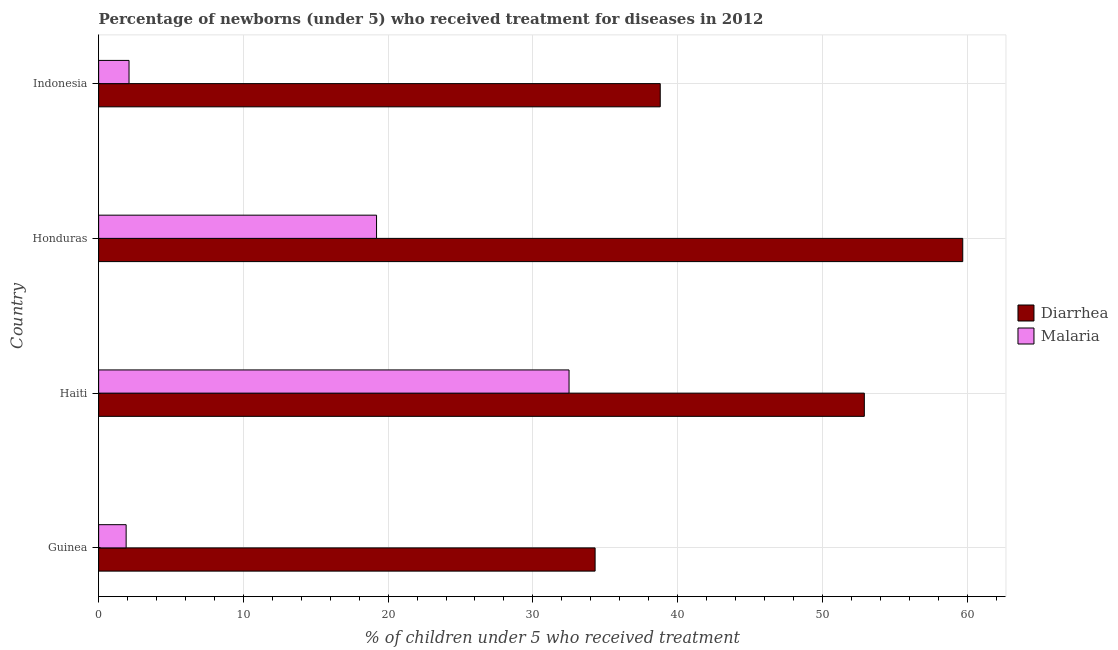How many groups of bars are there?
Your answer should be very brief. 4. Are the number of bars on each tick of the Y-axis equal?
Your answer should be compact. Yes. How many bars are there on the 1st tick from the top?
Your response must be concise. 2. What is the label of the 4th group of bars from the top?
Keep it short and to the point. Guinea. In how many cases, is the number of bars for a given country not equal to the number of legend labels?
Your answer should be compact. 0. What is the percentage of children who received treatment for diarrhoea in Haiti?
Keep it short and to the point. 52.9. Across all countries, what is the maximum percentage of children who received treatment for diarrhoea?
Your answer should be compact. 59.7. In which country was the percentage of children who received treatment for diarrhoea maximum?
Provide a succinct answer. Honduras. In which country was the percentage of children who received treatment for malaria minimum?
Provide a short and direct response. Guinea. What is the total percentage of children who received treatment for malaria in the graph?
Your answer should be compact. 55.7. What is the difference between the percentage of children who received treatment for malaria in Guinea and the percentage of children who received treatment for diarrhoea in Haiti?
Your answer should be compact. -51. What is the average percentage of children who received treatment for diarrhoea per country?
Give a very brief answer. 46.42. What is the difference between the percentage of children who received treatment for malaria and percentage of children who received treatment for diarrhoea in Honduras?
Your response must be concise. -40.5. In how many countries, is the percentage of children who received treatment for malaria greater than 44 %?
Provide a short and direct response. 0. What is the ratio of the percentage of children who received treatment for malaria in Haiti to that in Indonesia?
Give a very brief answer. 15.48. Is the percentage of children who received treatment for malaria in Guinea less than that in Honduras?
Your response must be concise. Yes. What is the difference between the highest and the lowest percentage of children who received treatment for diarrhoea?
Keep it short and to the point. 25.4. In how many countries, is the percentage of children who received treatment for diarrhoea greater than the average percentage of children who received treatment for diarrhoea taken over all countries?
Give a very brief answer. 2. What does the 1st bar from the top in Haiti represents?
Give a very brief answer. Malaria. What does the 2nd bar from the bottom in Honduras represents?
Give a very brief answer. Malaria. How many bars are there?
Make the answer very short. 8. Are all the bars in the graph horizontal?
Offer a terse response. Yes. Does the graph contain any zero values?
Offer a very short reply. No. Does the graph contain grids?
Your answer should be compact. Yes. How are the legend labels stacked?
Offer a terse response. Vertical. What is the title of the graph?
Provide a short and direct response. Percentage of newborns (under 5) who received treatment for diseases in 2012. Does "Mineral" appear as one of the legend labels in the graph?
Provide a succinct answer. No. What is the label or title of the X-axis?
Offer a very short reply. % of children under 5 who received treatment. What is the label or title of the Y-axis?
Offer a terse response. Country. What is the % of children under 5 who received treatment of Diarrhea in Guinea?
Your answer should be compact. 34.3. What is the % of children under 5 who received treatment of Malaria in Guinea?
Offer a terse response. 1.9. What is the % of children under 5 who received treatment of Diarrhea in Haiti?
Provide a succinct answer. 52.9. What is the % of children under 5 who received treatment in Malaria in Haiti?
Keep it short and to the point. 32.5. What is the % of children under 5 who received treatment in Diarrhea in Honduras?
Offer a very short reply. 59.7. What is the % of children under 5 who received treatment in Diarrhea in Indonesia?
Give a very brief answer. 38.8. What is the % of children under 5 who received treatment of Malaria in Indonesia?
Provide a succinct answer. 2.1. Across all countries, what is the maximum % of children under 5 who received treatment in Diarrhea?
Make the answer very short. 59.7. Across all countries, what is the maximum % of children under 5 who received treatment of Malaria?
Ensure brevity in your answer.  32.5. Across all countries, what is the minimum % of children under 5 who received treatment of Diarrhea?
Your response must be concise. 34.3. Across all countries, what is the minimum % of children under 5 who received treatment in Malaria?
Your response must be concise. 1.9. What is the total % of children under 5 who received treatment of Diarrhea in the graph?
Ensure brevity in your answer.  185.7. What is the total % of children under 5 who received treatment of Malaria in the graph?
Provide a succinct answer. 55.7. What is the difference between the % of children under 5 who received treatment of Diarrhea in Guinea and that in Haiti?
Make the answer very short. -18.6. What is the difference between the % of children under 5 who received treatment in Malaria in Guinea and that in Haiti?
Provide a succinct answer. -30.6. What is the difference between the % of children under 5 who received treatment in Diarrhea in Guinea and that in Honduras?
Keep it short and to the point. -25.4. What is the difference between the % of children under 5 who received treatment of Malaria in Guinea and that in Honduras?
Provide a succinct answer. -17.3. What is the difference between the % of children under 5 who received treatment in Diarrhea in Guinea and that in Indonesia?
Give a very brief answer. -4.5. What is the difference between the % of children under 5 who received treatment in Malaria in Guinea and that in Indonesia?
Offer a terse response. -0.2. What is the difference between the % of children under 5 who received treatment of Diarrhea in Haiti and that in Honduras?
Keep it short and to the point. -6.8. What is the difference between the % of children under 5 who received treatment in Diarrhea in Haiti and that in Indonesia?
Keep it short and to the point. 14.1. What is the difference between the % of children under 5 who received treatment in Malaria in Haiti and that in Indonesia?
Offer a terse response. 30.4. What is the difference between the % of children under 5 who received treatment in Diarrhea in Honduras and that in Indonesia?
Ensure brevity in your answer.  20.9. What is the difference between the % of children under 5 who received treatment of Malaria in Honduras and that in Indonesia?
Offer a terse response. 17.1. What is the difference between the % of children under 5 who received treatment of Diarrhea in Guinea and the % of children under 5 who received treatment of Malaria in Indonesia?
Your response must be concise. 32.2. What is the difference between the % of children under 5 who received treatment in Diarrhea in Haiti and the % of children under 5 who received treatment in Malaria in Honduras?
Your response must be concise. 33.7. What is the difference between the % of children under 5 who received treatment of Diarrhea in Haiti and the % of children under 5 who received treatment of Malaria in Indonesia?
Offer a very short reply. 50.8. What is the difference between the % of children under 5 who received treatment of Diarrhea in Honduras and the % of children under 5 who received treatment of Malaria in Indonesia?
Your answer should be very brief. 57.6. What is the average % of children under 5 who received treatment of Diarrhea per country?
Offer a very short reply. 46.42. What is the average % of children under 5 who received treatment in Malaria per country?
Offer a terse response. 13.93. What is the difference between the % of children under 5 who received treatment in Diarrhea and % of children under 5 who received treatment in Malaria in Guinea?
Provide a succinct answer. 32.4. What is the difference between the % of children under 5 who received treatment in Diarrhea and % of children under 5 who received treatment in Malaria in Haiti?
Your answer should be very brief. 20.4. What is the difference between the % of children under 5 who received treatment of Diarrhea and % of children under 5 who received treatment of Malaria in Honduras?
Make the answer very short. 40.5. What is the difference between the % of children under 5 who received treatment of Diarrhea and % of children under 5 who received treatment of Malaria in Indonesia?
Give a very brief answer. 36.7. What is the ratio of the % of children under 5 who received treatment of Diarrhea in Guinea to that in Haiti?
Keep it short and to the point. 0.65. What is the ratio of the % of children under 5 who received treatment in Malaria in Guinea to that in Haiti?
Make the answer very short. 0.06. What is the ratio of the % of children under 5 who received treatment in Diarrhea in Guinea to that in Honduras?
Provide a short and direct response. 0.57. What is the ratio of the % of children under 5 who received treatment in Malaria in Guinea to that in Honduras?
Make the answer very short. 0.1. What is the ratio of the % of children under 5 who received treatment in Diarrhea in Guinea to that in Indonesia?
Provide a short and direct response. 0.88. What is the ratio of the % of children under 5 who received treatment of Malaria in Guinea to that in Indonesia?
Provide a succinct answer. 0.9. What is the ratio of the % of children under 5 who received treatment in Diarrhea in Haiti to that in Honduras?
Make the answer very short. 0.89. What is the ratio of the % of children under 5 who received treatment of Malaria in Haiti to that in Honduras?
Make the answer very short. 1.69. What is the ratio of the % of children under 5 who received treatment in Diarrhea in Haiti to that in Indonesia?
Your answer should be compact. 1.36. What is the ratio of the % of children under 5 who received treatment in Malaria in Haiti to that in Indonesia?
Your response must be concise. 15.48. What is the ratio of the % of children under 5 who received treatment of Diarrhea in Honduras to that in Indonesia?
Offer a very short reply. 1.54. What is the ratio of the % of children under 5 who received treatment of Malaria in Honduras to that in Indonesia?
Your answer should be compact. 9.14. What is the difference between the highest and the second highest % of children under 5 who received treatment in Malaria?
Keep it short and to the point. 13.3. What is the difference between the highest and the lowest % of children under 5 who received treatment in Diarrhea?
Your response must be concise. 25.4. What is the difference between the highest and the lowest % of children under 5 who received treatment of Malaria?
Offer a terse response. 30.6. 